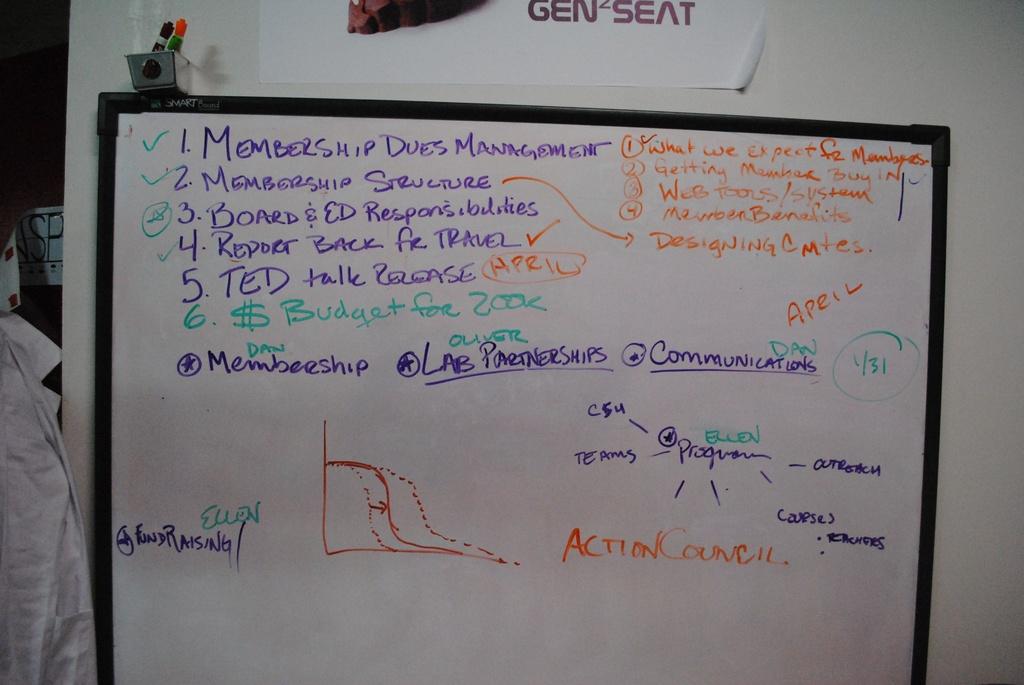What is written next to number 2?
Provide a succinct answer. Membership structure. 